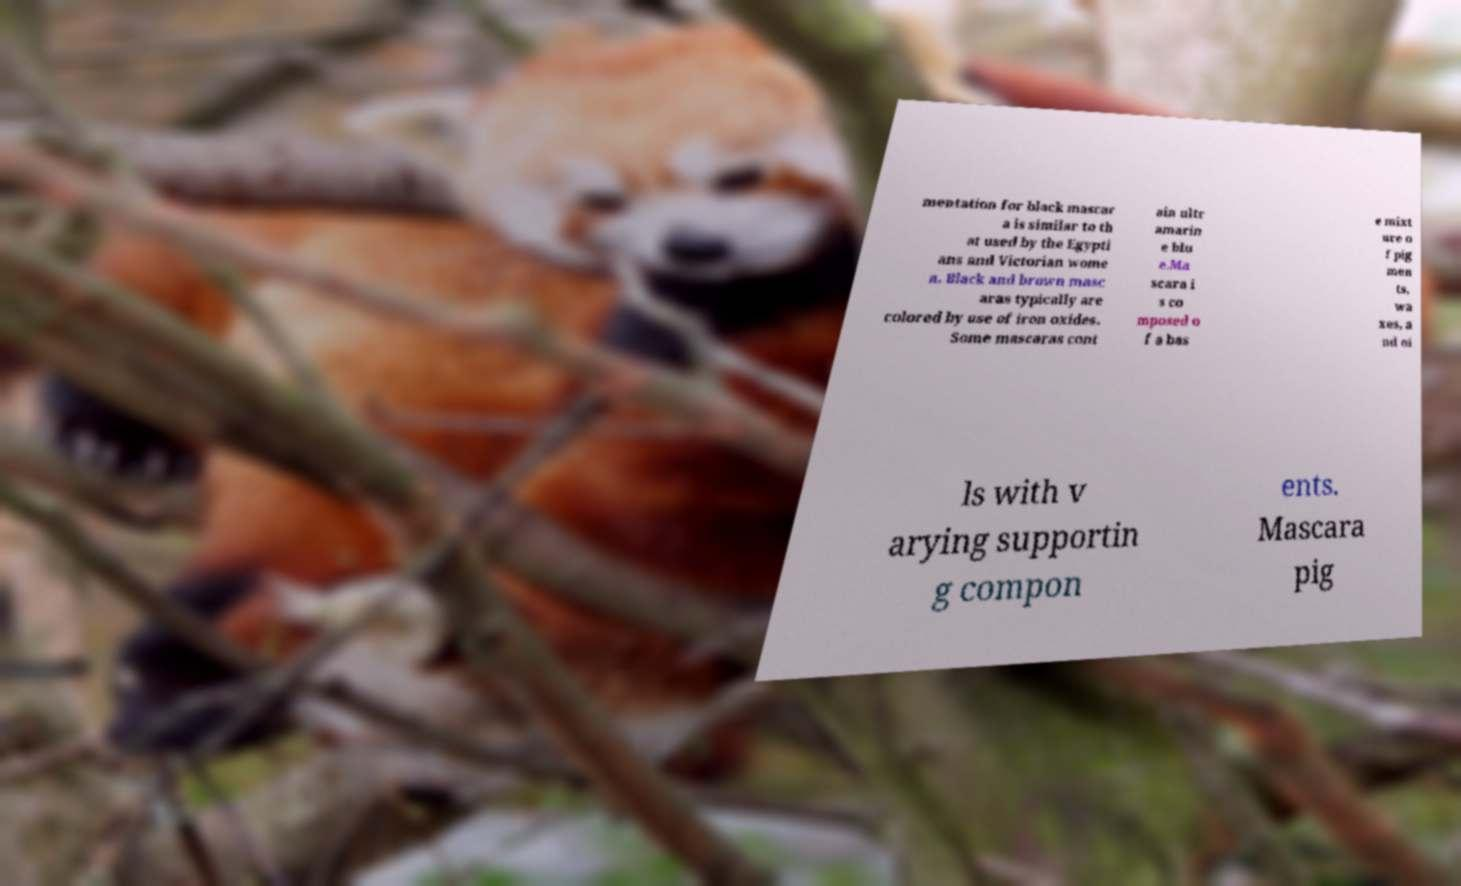There's text embedded in this image that I need extracted. Can you transcribe it verbatim? mentation for black mascar a is similar to th at used by the Egypti ans and Victorian wome n. Black and brown masc aras typically are colored by use of iron oxides. Some mascaras cont ain ultr amarin e blu e.Ma scara i s co mposed o f a bas e mixt ure o f pig men ts, wa xes, a nd oi ls with v arying supportin g compon ents. Mascara pig 